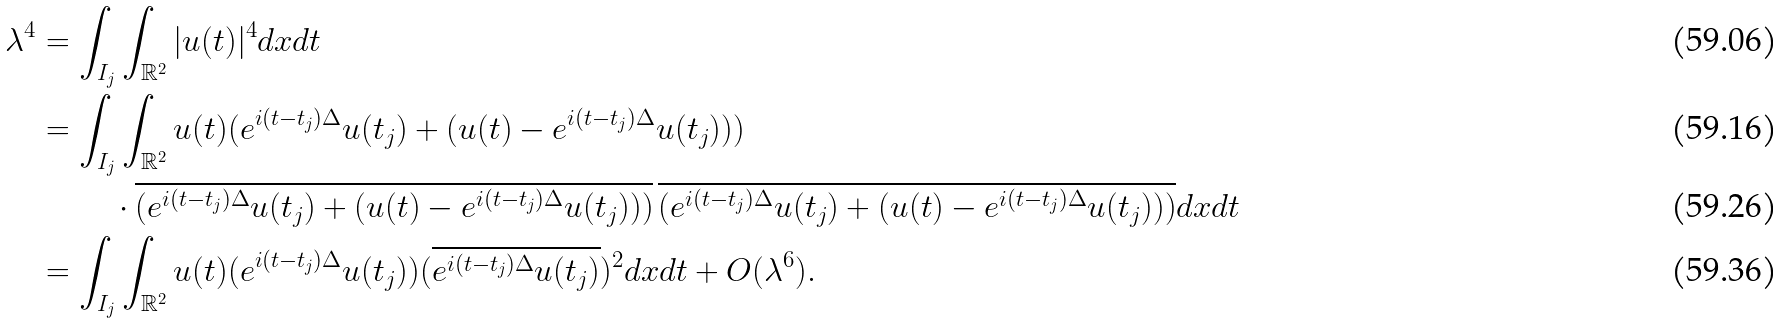Convert formula to latex. <formula><loc_0><loc_0><loc_500><loc_500>\lambda ^ { 4 } & = \int _ { I _ { j } } \int _ { \mathbb { R } ^ { 2 } } | u ( t ) | ^ { 4 } d x d t \\ & = \int _ { I _ { j } } \int _ { \mathbb { R } ^ { 2 } } u ( t ) ( e ^ { i ( t - t _ { j } ) \Delta } u ( t _ { j } ) + ( u ( t ) - e ^ { i ( t - t _ { j } ) \Delta } u ( t _ { j } ) ) ) \\ & \quad \ \quad \cdot \overline { ( e ^ { i ( t - t _ { j } ) \Delta } u ( t _ { j } ) + ( u ( t ) - e ^ { i ( t - t _ { j } ) \Delta } u ( t _ { j } ) ) ) } \, \overline { ( e ^ { i ( t - t _ { j } ) \Delta } u ( t _ { j } ) + ( u ( t ) - e ^ { i ( t - t _ { j } ) \Delta } u ( t _ { j } ) ) ) } d x d t \\ & = \int _ { I _ { j } } \int _ { \mathbb { R } ^ { 2 } } u ( t ) ( e ^ { i ( t - t _ { j } ) \Delta } u ( t _ { j } ) ) ( \overline { e ^ { i ( t - t _ { j } ) \Delta } u ( t _ { j } ) } ) ^ { 2 } d x d t + O ( \lambda ^ { 6 } ) .</formula> 